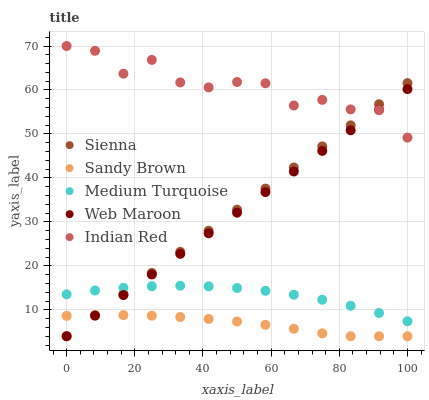Does Sandy Brown have the minimum area under the curve?
Answer yes or no. Yes. Does Indian Red have the maximum area under the curve?
Answer yes or no. Yes. Does Web Maroon have the minimum area under the curve?
Answer yes or no. No. Does Web Maroon have the maximum area under the curve?
Answer yes or no. No. Is Web Maroon the smoothest?
Answer yes or no. Yes. Is Indian Red the roughest?
Answer yes or no. Yes. Is Sandy Brown the smoothest?
Answer yes or no. No. Is Sandy Brown the roughest?
Answer yes or no. No. Does Sienna have the lowest value?
Answer yes or no. Yes. Does Indian Red have the lowest value?
Answer yes or no. No. Does Indian Red have the highest value?
Answer yes or no. Yes. Does Web Maroon have the highest value?
Answer yes or no. No. Is Sandy Brown less than Medium Turquoise?
Answer yes or no. Yes. Is Indian Red greater than Medium Turquoise?
Answer yes or no. Yes. Does Medium Turquoise intersect Web Maroon?
Answer yes or no. Yes. Is Medium Turquoise less than Web Maroon?
Answer yes or no. No. Is Medium Turquoise greater than Web Maroon?
Answer yes or no. No. Does Sandy Brown intersect Medium Turquoise?
Answer yes or no. No. 